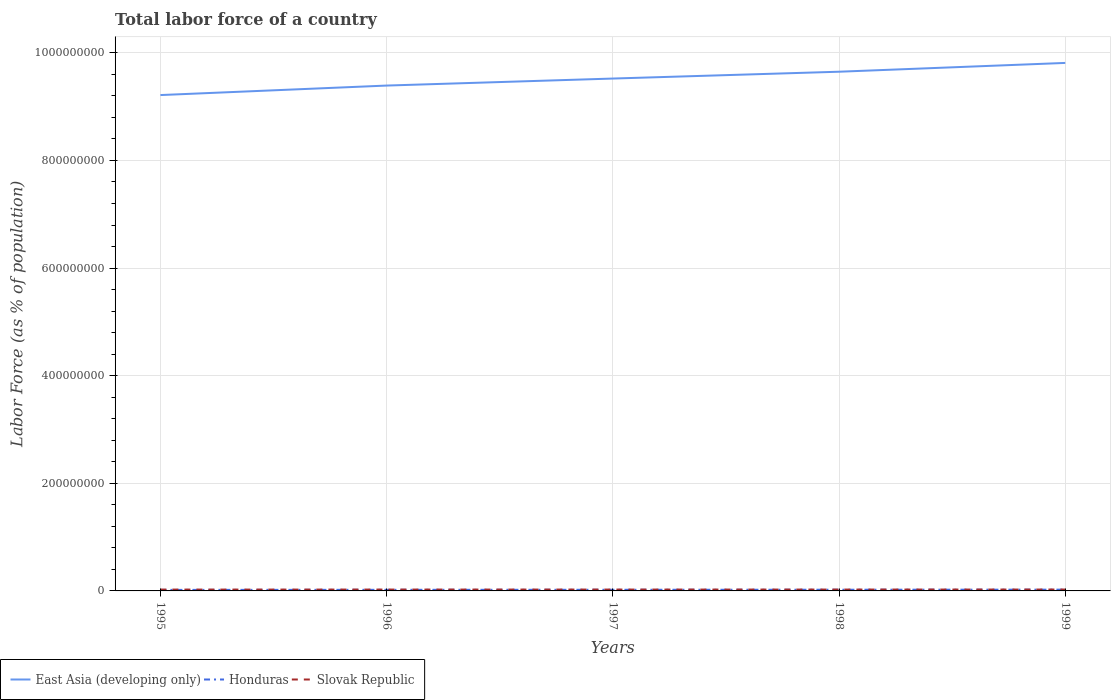Across all years, what is the maximum percentage of labor force in East Asia (developing only)?
Provide a short and direct response. 9.21e+08. In which year was the percentage of labor force in Honduras maximum?
Make the answer very short. 1995. What is the total percentage of labor force in Slovak Republic in the graph?
Make the answer very short. -1.93e+04. What is the difference between the highest and the second highest percentage of labor force in Honduras?
Keep it short and to the point. 4.53e+05. Is the percentage of labor force in East Asia (developing only) strictly greater than the percentage of labor force in Slovak Republic over the years?
Provide a succinct answer. No. How many lines are there?
Keep it short and to the point. 3. How many years are there in the graph?
Your response must be concise. 5. Does the graph contain any zero values?
Offer a terse response. No. Does the graph contain grids?
Offer a very short reply. Yes. How many legend labels are there?
Make the answer very short. 3. What is the title of the graph?
Ensure brevity in your answer.  Total labor force of a country. Does "East Asia (all income levels)" appear as one of the legend labels in the graph?
Give a very brief answer. No. What is the label or title of the X-axis?
Offer a terse response. Years. What is the label or title of the Y-axis?
Ensure brevity in your answer.  Labor Force (as % of population). What is the Labor Force (as % of population) of East Asia (developing only) in 1995?
Ensure brevity in your answer.  9.21e+08. What is the Labor Force (as % of population) of Honduras in 1995?
Your response must be concise. 1.89e+06. What is the Labor Force (as % of population) of Slovak Republic in 1995?
Provide a short and direct response. 2.48e+06. What is the Labor Force (as % of population) of East Asia (developing only) in 1996?
Make the answer very short. 9.39e+08. What is the Labor Force (as % of population) in Honduras in 1996?
Offer a very short reply. 2.04e+06. What is the Labor Force (as % of population) in Slovak Republic in 1996?
Your answer should be compact. 2.52e+06. What is the Labor Force (as % of population) in East Asia (developing only) in 1997?
Your answer should be compact. 9.52e+08. What is the Labor Force (as % of population) in Honduras in 1997?
Offer a very short reply. 2.11e+06. What is the Labor Force (as % of population) of Slovak Republic in 1997?
Your response must be concise. 2.52e+06. What is the Labor Force (as % of population) in East Asia (developing only) in 1998?
Your answer should be very brief. 9.65e+08. What is the Labor Force (as % of population) of Honduras in 1998?
Keep it short and to the point. 2.21e+06. What is the Labor Force (as % of population) of Slovak Republic in 1998?
Offer a terse response. 2.54e+06. What is the Labor Force (as % of population) in East Asia (developing only) in 1999?
Provide a succinct answer. 9.81e+08. What is the Labor Force (as % of population) of Honduras in 1999?
Your answer should be compact. 2.35e+06. What is the Labor Force (as % of population) in Slovak Republic in 1999?
Offer a terse response. 2.57e+06. Across all years, what is the maximum Labor Force (as % of population) in East Asia (developing only)?
Offer a very short reply. 9.81e+08. Across all years, what is the maximum Labor Force (as % of population) in Honduras?
Make the answer very short. 2.35e+06. Across all years, what is the maximum Labor Force (as % of population) of Slovak Republic?
Your answer should be very brief. 2.57e+06. Across all years, what is the minimum Labor Force (as % of population) in East Asia (developing only)?
Keep it short and to the point. 9.21e+08. Across all years, what is the minimum Labor Force (as % of population) in Honduras?
Keep it short and to the point. 1.89e+06. Across all years, what is the minimum Labor Force (as % of population) of Slovak Republic?
Offer a terse response. 2.48e+06. What is the total Labor Force (as % of population) of East Asia (developing only) in the graph?
Make the answer very short. 4.76e+09. What is the total Labor Force (as % of population) of Honduras in the graph?
Your answer should be very brief. 1.06e+07. What is the total Labor Force (as % of population) in Slovak Republic in the graph?
Ensure brevity in your answer.  1.26e+07. What is the difference between the Labor Force (as % of population) in East Asia (developing only) in 1995 and that in 1996?
Offer a terse response. -1.77e+07. What is the difference between the Labor Force (as % of population) in Honduras in 1995 and that in 1996?
Your response must be concise. -1.48e+05. What is the difference between the Labor Force (as % of population) of Slovak Republic in 1995 and that in 1996?
Give a very brief answer. -3.65e+04. What is the difference between the Labor Force (as % of population) in East Asia (developing only) in 1995 and that in 1997?
Offer a very short reply. -3.07e+07. What is the difference between the Labor Force (as % of population) in Honduras in 1995 and that in 1997?
Ensure brevity in your answer.  -2.17e+05. What is the difference between the Labor Force (as % of population) in Slovak Republic in 1995 and that in 1997?
Provide a succinct answer. -3.57e+04. What is the difference between the Labor Force (as % of population) of East Asia (developing only) in 1995 and that in 1998?
Make the answer very short. -4.34e+07. What is the difference between the Labor Force (as % of population) of Honduras in 1995 and that in 1998?
Your answer should be compact. -3.16e+05. What is the difference between the Labor Force (as % of population) in Slovak Republic in 1995 and that in 1998?
Ensure brevity in your answer.  -5.50e+04. What is the difference between the Labor Force (as % of population) of East Asia (developing only) in 1995 and that in 1999?
Your answer should be very brief. -5.97e+07. What is the difference between the Labor Force (as % of population) of Honduras in 1995 and that in 1999?
Give a very brief answer. -4.53e+05. What is the difference between the Labor Force (as % of population) of Slovak Republic in 1995 and that in 1999?
Offer a very short reply. -9.08e+04. What is the difference between the Labor Force (as % of population) in East Asia (developing only) in 1996 and that in 1997?
Offer a very short reply. -1.30e+07. What is the difference between the Labor Force (as % of population) of Honduras in 1996 and that in 1997?
Offer a very short reply. -6.93e+04. What is the difference between the Labor Force (as % of population) of Slovak Republic in 1996 and that in 1997?
Your answer should be compact. 828. What is the difference between the Labor Force (as % of population) of East Asia (developing only) in 1996 and that in 1998?
Offer a very short reply. -2.57e+07. What is the difference between the Labor Force (as % of population) in Honduras in 1996 and that in 1998?
Offer a very short reply. -1.68e+05. What is the difference between the Labor Force (as % of population) of Slovak Republic in 1996 and that in 1998?
Keep it short and to the point. -1.85e+04. What is the difference between the Labor Force (as % of population) in East Asia (developing only) in 1996 and that in 1999?
Your answer should be compact. -4.21e+07. What is the difference between the Labor Force (as % of population) of Honduras in 1996 and that in 1999?
Make the answer very short. -3.05e+05. What is the difference between the Labor Force (as % of population) in Slovak Republic in 1996 and that in 1999?
Your answer should be compact. -5.43e+04. What is the difference between the Labor Force (as % of population) in East Asia (developing only) in 1997 and that in 1998?
Provide a succinct answer. -1.27e+07. What is the difference between the Labor Force (as % of population) in Honduras in 1997 and that in 1998?
Offer a very short reply. -9.85e+04. What is the difference between the Labor Force (as % of population) of Slovak Republic in 1997 and that in 1998?
Make the answer very short. -1.93e+04. What is the difference between the Labor Force (as % of population) of East Asia (developing only) in 1997 and that in 1999?
Your response must be concise. -2.90e+07. What is the difference between the Labor Force (as % of population) in Honduras in 1997 and that in 1999?
Your response must be concise. -2.35e+05. What is the difference between the Labor Force (as % of population) in Slovak Republic in 1997 and that in 1999?
Offer a very short reply. -5.51e+04. What is the difference between the Labor Force (as % of population) of East Asia (developing only) in 1998 and that in 1999?
Ensure brevity in your answer.  -1.63e+07. What is the difference between the Labor Force (as % of population) of Honduras in 1998 and that in 1999?
Give a very brief answer. -1.37e+05. What is the difference between the Labor Force (as % of population) in Slovak Republic in 1998 and that in 1999?
Your answer should be compact. -3.58e+04. What is the difference between the Labor Force (as % of population) of East Asia (developing only) in 1995 and the Labor Force (as % of population) of Honduras in 1996?
Ensure brevity in your answer.  9.19e+08. What is the difference between the Labor Force (as % of population) in East Asia (developing only) in 1995 and the Labor Force (as % of population) in Slovak Republic in 1996?
Offer a very short reply. 9.19e+08. What is the difference between the Labor Force (as % of population) of Honduras in 1995 and the Labor Force (as % of population) of Slovak Republic in 1996?
Provide a succinct answer. -6.23e+05. What is the difference between the Labor Force (as % of population) in East Asia (developing only) in 1995 and the Labor Force (as % of population) in Honduras in 1997?
Your response must be concise. 9.19e+08. What is the difference between the Labor Force (as % of population) of East Asia (developing only) in 1995 and the Labor Force (as % of population) of Slovak Republic in 1997?
Your answer should be very brief. 9.19e+08. What is the difference between the Labor Force (as % of population) of Honduras in 1995 and the Labor Force (as % of population) of Slovak Republic in 1997?
Your answer should be compact. -6.22e+05. What is the difference between the Labor Force (as % of population) in East Asia (developing only) in 1995 and the Labor Force (as % of population) in Honduras in 1998?
Your response must be concise. 9.19e+08. What is the difference between the Labor Force (as % of population) in East Asia (developing only) in 1995 and the Labor Force (as % of population) in Slovak Republic in 1998?
Provide a succinct answer. 9.19e+08. What is the difference between the Labor Force (as % of population) of Honduras in 1995 and the Labor Force (as % of population) of Slovak Republic in 1998?
Your answer should be very brief. -6.42e+05. What is the difference between the Labor Force (as % of population) in East Asia (developing only) in 1995 and the Labor Force (as % of population) in Honduras in 1999?
Provide a short and direct response. 9.19e+08. What is the difference between the Labor Force (as % of population) in East Asia (developing only) in 1995 and the Labor Force (as % of population) in Slovak Republic in 1999?
Your response must be concise. 9.19e+08. What is the difference between the Labor Force (as % of population) of Honduras in 1995 and the Labor Force (as % of population) of Slovak Republic in 1999?
Offer a terse response. -6.77e+05. What is the difference between the Labor Force (as % of population) in East Asia (developing only) in 1996 and the Labor Force (as % of population) in Honduras in 1997?
Provide a short and direct response. 9.37e+08. What is the difference between the Labor Force (as % of population) in East Asia (developing only) in 1996 and the Labor Force (as % of population) in Slovak Republic in 1997?
Offer a terse response. 9.37e+08. What is the difference between the Labor Force (as % of population) of Honduras in 1996 and the Labor Force (as % of population) of Slovak Republic in 1997?
Your answer should be compact. -4.74e+05. What is the difference between the Labor Force (as % of population) of East Asia (developing only) in 1996 and the Labor Force (as % of population) of Honduras in 1998?
Offer a very short reply. 9.37e+08. What is the difference between the Labor Force (as % of population) of East Asia (developing only) in 1996 and the Labor Force (as % of population) of Slovak Republic in 1998?
Provide a short and direct response. 9.37e+08. What is the difference between the Labor Force (as % of population) in Honduras in 1996 and the Labor Force (as % of population) in Slovak Republic in 1998?
Make the answer very short. -4.94e+05. What is the difference between the Labor Force (as % of population) of East Asia (developing only) in 1996 and the Labor Force (as % of population) of Honduras in 1999?
Make the answer very short. 9.37e+08. What is the difference between the Labor Force (as % of population) in East Asia (developing only) in 1996 and the Labor Force (as % of population) in Slovak Republic in 1999?
Offer a terse response. 9.37e+08. What is the difference between the Labor Force (as % of population) in Honduras in 1996 and the Labor Force (as % of population) in Slovak Republic in 1999?
Offer a terse response. -5.29e+05. What is the difference between the Labor Force (as % of population) in East Asia (developing only) in 1997 and the Labor Force (as % of population) in Honduras in 1998?
Your answer should be compact. 9.50e+08. What is the difference between the Labor Force (as % of population) of East Asia (developing only) in 1997 and the Labor Force (as % of population) of Slovak Republic in 1998?
Give a very brief answer. 9.50e+08. What is the difference between the Labor Force (as % of population) in Honduras in 1997 and the Labor Force (as % of population) in Slovak Republic in 1998?
Ensure brevity in your answer.  -4.24e+05. What is the difference between the Labor Force (as % of population) of East Asia (developing only) in 1997 and the Labor Force (as % of population) of Honduras in 1999?
Give a very brief answer. 9.50e+08. What is the difference between the Labor Force (as % of population) of East Asia (developing only) in 1997 and the Labor Force (as % of population) of Slovak Republic in 1999?
Your answer should be very brief. 9.50e+08. What is the difference between the Labor Force (as % of population) in Honduras in 1997 and the Labor Force (as % of population) in Slovak Republic in 1999?
Provide a succinct answer. -4.60e+05. What is the difference between the Labor Force (as % of population) of East Asia (developing only) in 1998 and the Labor Force (as % of population) of Honduras in 1999?
Provide a short and direct response. 9.63e+08. What is the difference between the Labor Force (as % of population) of East Asia (developing only) in 1998 and the Labor Force (as % of population) of Slovak Republic in 1999?
Your answer should be very brief. 9.62e+08. What is the difference between the Labor Force (as % of population) of Honduras in 1998 and the Labor Force (as % of population) of Slovak Republic in 1999?
Keep it short and to the point. -3.62e+05. What is the average Labor Force (as % of population) of East Asia (developing only) per year?
Keep it short and to the point. 9.52e+08. What is the average Labor Force (as % of population) in Honduras per year?
Give a very brief answer. 2.12e+06. What is the average Labor Force (as % of population) of Slovak Republic per year?
Make the answer very short. 2.52e+06. In the year 1995, what is the difference between the Labor Force (as % of population) of East Asia (developing only) and Labor Force (as % of population) of Honduras?
Offer a very short reply. 9.20e+08. In the year 1995, what is the difference between the Labor Force (as % of population) in East Asia (developing only) and Labor Force (as % of population) in Slovak Republic?
Your answer should be very brief. 9.19e+08. In the year 1995, what is the difference between the Labor Force (as % of population) of Honduras and Labor Force (as % of population) of Slovak Republic?
Ensure brevity in your answer.  -5.87e+05. In the year 1996, what is the difference between the Labor Force (as % of population) of East Asia (developing only) and Labor Force (as % of population) of Honduras?
Offer a very short reply. 9.37e+08. In the year 1996, what is the difference between the Labor Force (as % of population) of East Asia (developing only) and Labor Force (as % of population) of Slovak Republic?
Give a very brief answer. 9.37e+08. In the year 1996, what is the difference between the Labor Force (as % of population) of Honduras and Labor Force (as % of population) of Slovak Republic?
Keep it short and to the point. -4.75e+05. In the year 1997, what is the difference between the Labor Force (as % of population) in East Asia (developing only) and Labor Force (as % of population) in Honduras?
Your answer should be very brief. 9.50e+08. In the year 1997, what is the difference between the Labor Force (as % of population) in East Asia (developing only) and Labor Force (as % of population) in Slovak Republic?
Your answer should be compact. 9.50e+08. In the year 1997, what is the difference between the Labor Force (as % of population) in Honduras and Labor Force (as % of population) in Slovak Republic?
Your answer should be very brief. -4.05e+05. In the year 1998, what is the difference between the Labor Force (as % of population) in East Asia (developing only) and Labor Force (as % of population) in Honduras?
Provide a short and direct response. 9.63e+08. In the year 1998, what is the difference between the Labor Force (as % of population) in East Asia (developing only) and Labor Force (as % of population) in Slovak Republic?
Your response must be concise. 9.62e+08. In the year 1998, what is the difference between the Labor Force (as % of population) of Honduras and Labor Force (as % of population) of Slovak Republic?
Your answer should be very brief. -3.26e+05. In the year 1999, what is the difference between the Labor Force (as % of population) of East Asia (developing only) and Labor Force (as % of population) of Honduras?
Offer a very short reply. 9.79e+08. In the year 1999, what is the difference between the Labor Force (as % of population) in East Asia (developing only) and Labor Force (as % of population) in Slovak Republic?
Your answer should be very brief. 9.79e+08. In the year 1999, what is the difference between the Labor Force (as % of population) of Honduras and Labor Force (as % of population) of Slovak Republic?
Ensure brevity in your answer.  -2.25e+05. What is the ratio of the Labor Force (as % of population) in East Asia (developing only) in 1995 to that in 1996?
Offer a very short reply. 0.98. What is the ratio of the Labor Force (as % of population) in Honduras in 1995 to that in 1996?
Offer a terse response. 0.93. What is the ratio of the Labor Force (as % of population) of Slovak Republic in 1995 to that in 1996?
Your answer should be very brief. 0.99. What is the ratio of the Labor Force (as % of population) of East Asia (developing only) in 1995 to that in 1997?
Make the answer very short. 0.97. What is the ratio of the Labor Force (as % of population) of Honduras in 1995 to that in 1997?
Ensure brevity in your answer.  0.9. What is the ratio of the Labor Force (as % of population) in Slovak Republic in 1995 to that in 1997?
Offer a very short reply. 0.99. What is the ratio of the Labor Force (as % of population) of East Asia (developing only) in 1995 to that in 1998?
Provide a succinct answer. 0.95. What is the ratio of the Labor Force (as % of population) of Slovak Republic in 1995 to that in 1998?
Keep it short and to the point. 0.98. What is the ratio of the Labor Force (as % of population) in East Asia (developing only) in 1995 to that in 1999?
Ensure brevity in your answer.  0.94. What is the ratio of the Labor Force (as % of population) of Honduras in 1995 to that in 1999?
Your answer should be very brief. 0.81. What is the ratio of the Labor Force (as % of population) in Slovak Republic in 1995 to that in 1999?
Ensure brevity in your answer.  0.96. What is the ratio of the Labor Force (as % of population) in East Asia (developing only) in 1996 to that in 1997?
Provide a short and direct response. 0.99. What is the ratio of the Labor Force (as % of population) in Honduras in 1996 to that in 1997?
Your answer should be compact. 0.97. What is the ratio of the Labor Force (as % of population) of East Asia (developing only) in 1996 to that in 1998?
Provide a succinct answer. 0.97. What is the ratio of the Labor Force (as % of population) of Honduras in 1996 to that in 1998?
Your answer should be very brief. 0.92. What is the ratio of the Labor Force (as % of population) of East Asia (developing only) in 1996 to that in 1999?
Make the answer very short. 0.96. What is the ratio of the Labor Force (as % of population) in Honduras in 1996 to that in 1999?
Give a very brief answer. 0.87. What is the ratio of the Labor Force (as % of population) of Slovak Republic in 1996 to that in 1999?
Make the answer very short. 0.98. What is the ratio of the Labor Force (as % of population) of East Asia (developing only) in 1997 to that in 1998?
Provide a short and direct response. 0.99. What is the ratio of the Labor Force (as % of population) of Honduras in 1997 to that in 1998?
Provide a short and direct response. 0.96. What is the ratio of the Labor Force (as % of population) of Slovak Republic in 1997 to that in 1998?
Give a very brief answer. 0.99. What is the ratio of the Labor Force (as % of population) in East Asia (developing only) in 1997 to that in 1999?
Ensure brevity in your answer.  0.97. What is the ratio of the Labor Force (as % of population) in Honduras in 1997 to that in 1999?
Offer a very short reply. 0.9. What is the ratio of the Labor Force (as % of population) in Slovak Republic in 1997 to that in 1999?
Your answer should be very brief. 0.98. What is the ratio of the Labor Force (as % of population) of East Asia (developing only) in 1998 to that in 1999?
Your answer should be compact. 0.98. What is the ratio of the Labor Force (as % of population) of Honduras in 1998 to that in 1999?
Your answer should be very brief. 0.94. What is the ratio of the Labor Force (as % of population) in Slovak Republic in 1998 to that in 1999?
Offer a very short reply. 0.99. What is the difference between the highest and the second highest Labor Force (as % of population) of East Asia (developing only)?
Provide a succinct answer. 1.63e+07. What is the difference between the highest and the second highest Labor Force (as % of population) in Honduras?
Give a very brief answer. 1.37e+05. What is the difference between the highest and the second highest Labor Force (as % of population) in Slovak Republic?
Your answer should be very brief. 3.58e+04. What is the difference between the highest and the lowest Labor Force (as % of population) of East Asia (developing only)?
Provide a succinct answer. 5.97e+07. What is the difference between the highest and the lowest Labor Force (as % of population) in Honduras?
Provide a short and direct response. 4.53e+05. What is the difference between the highest and the lowest Labor Force (as % of population) in Slovak Republic?
Provide a succinct answer. 9.08e+04. 